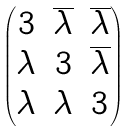<formula> <loc_0><loc_0><loc_500><loc_500>\begin{pmatrix} 3 & \overline { \lambda } & \overline { \lambda } \\ \lambda & 3 & \overline { \lambda } \\ \lambda & \lambda & 3 \end{pmatrix}</formula> 